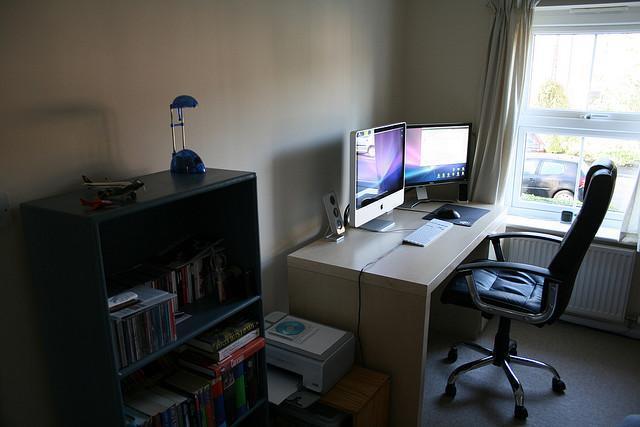How many monitors are on the desk?
Give a very brief answer. 2. How many tvs are there?
Give a very brief answer. 2. 